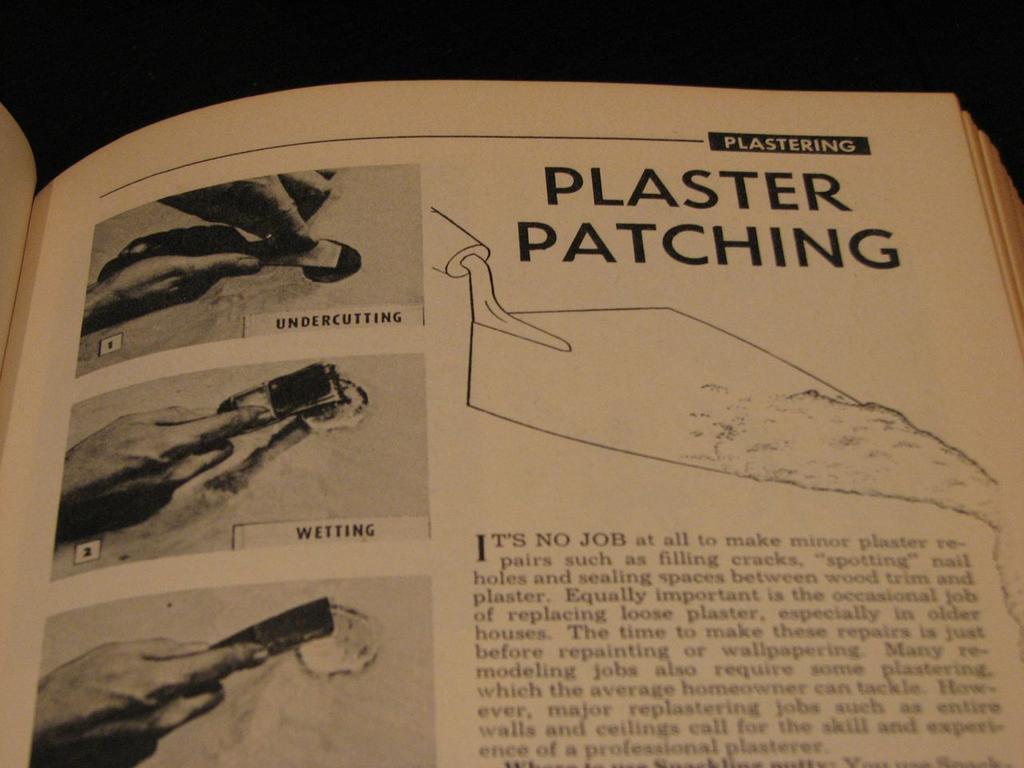Which section does plaster patching belong to in the book?
Provide a succinct answer. Plastering. 